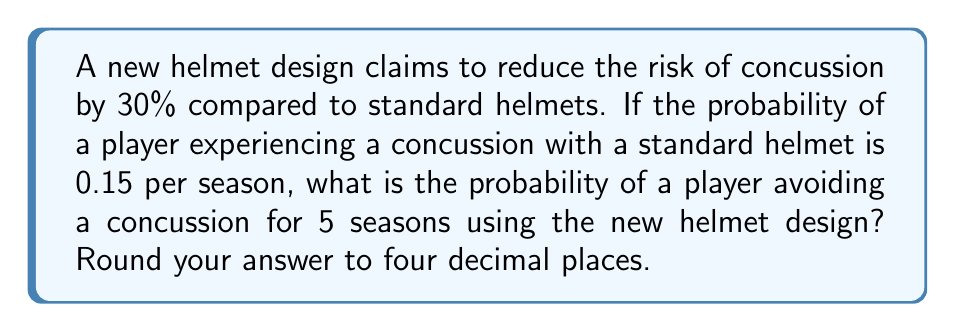Can you solve this math problem? Let's approach this step-by-step:

1) First, let's calculate the probability of experiencing a concussion with the new helmet design:
   
   Standard helmet probability: 0.15
   Reduction: 30% = 0.30
   
   New probability = $0.15 \times (1 - 0.30) = 0.15 \times 0.70 = 0.105$

2) Now, we need to find the probability of avoiding a concussion for one season:
   
   Probability of avoiding concussion = $1 - 0.105 = 0.895$

3) To calculate the probability of avoiding a concussion for 5 seasons, we need to raise this probability to the power of 5:

   $$P(\text{avoiding concussion for 5 seasons}) = 0.895^5$$

4) Let's calculate this:
   
   $$0.895^5 \approx 0.5700124$$

5) Rounding to four decimal places:

   $$0.5700124 \approx 0.5700$$

Therefore, the probability of a player avoiding a concussion for 5 seasons using the new helmet design is approximately 0.5700 or 57.00%.
Answer: 0.5700 